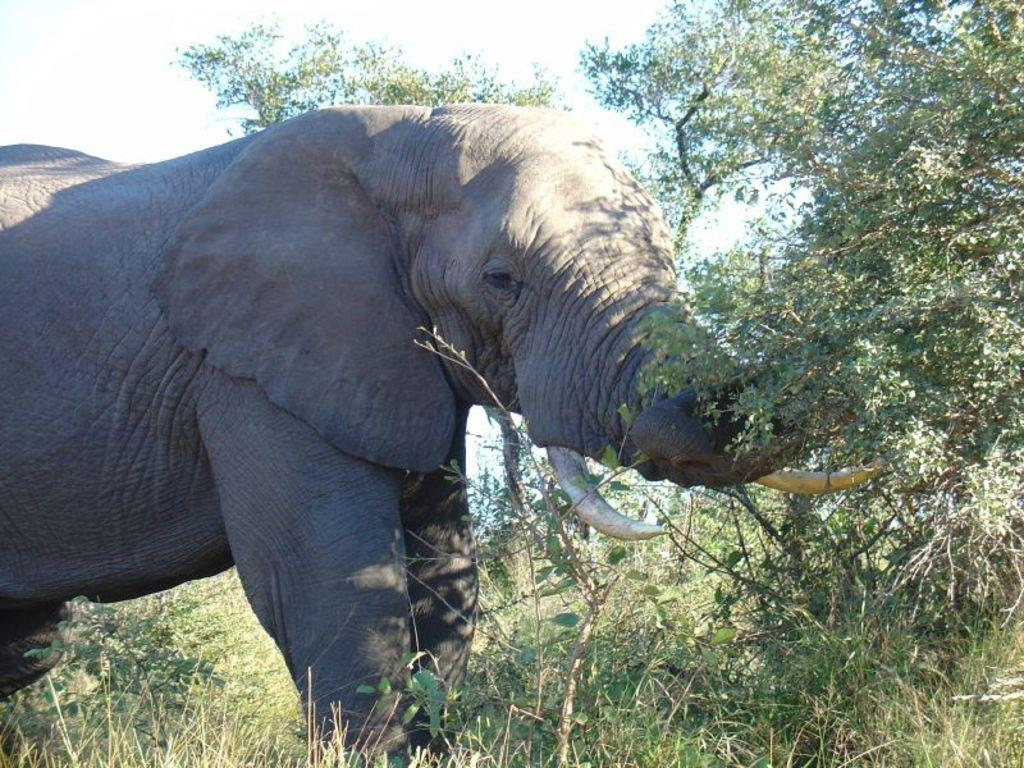What animal is present in the picture? There is an elephant in the picture. What type of vegetation can be seen in the picture? There is grass and plants in the picture. What part of the natural environment is visible in the picture? The sky is visible in the picture. What event are the friends attending in the picture? There is no mention of friends or an event in the picture; it features an elephant, grass, plants, and the sky. 